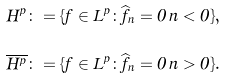Convert formula to latex. <formula><loc_0><loc_0><loc_500><loc_500>H ^ { p } \colon = \{ f \in L ^ { p } \colon \widehat { f } _ { n } = 0 \, n < 0 \} , \\ \overline { H ^ { p } } \colon = \{ f \in L ^ { p } \colon \widehat { f } _ { n } = 0 \, n > 0 \} .</formula> 